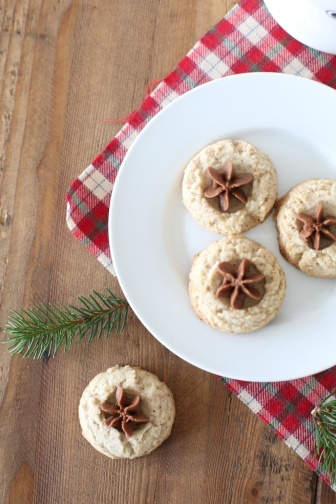Describe the following image.
 The image captures a cozy scene on a wooden table. Dominating the scene is a white, round plate holding three cookies. Each cookie is round and topped with a star anise, adding a touch of rustic charm to the arrangement. The plate is placed on a red and white checkered napkin, which contrasts beautifully with the wooden table.

To the side of the plate, there's a fourth cookie resting directly on the table. This cookie mirrors its counterparts on the plate, round in shape and adorned with a star anise. 

Adding a touch of nature to the scene, a sprig of greenery is casually placed on the table. Its vibrant color stands out against the warm tones of the cookies and the wood.

The entire scene is a harmonious blend of objects, colors, and textures. The precise placement of each item creates a balanced composition, inviting the viewer to appreciate the simple beauty of everyday objects. 